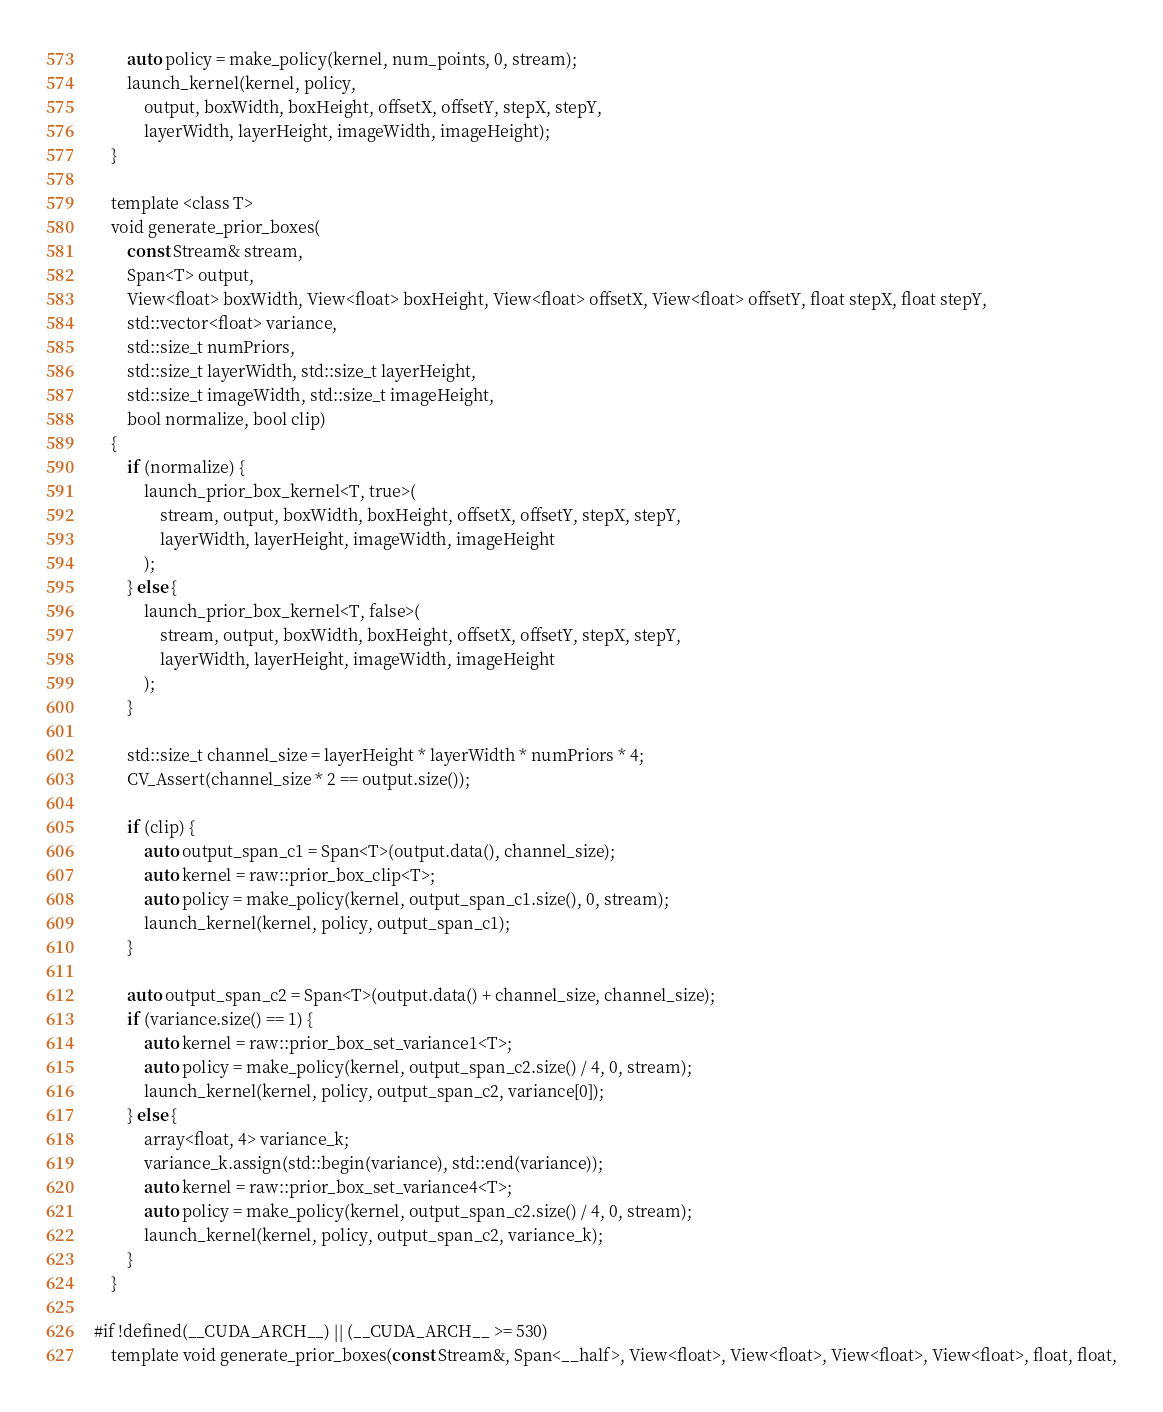Convert code to text. <code><loc_0><loc_0><loc_500><loc_500><_Cuda_>        auto policy = make_policy(kernel, num_points, 0, stream);
        launch_kernel(kernel, policy,
            output, boxWidth, boxHeight, offsetX, offsetY, stepX, stepY,
            layerWidth, layerHeight, imageWidth, imageHeight);
    }

    template <class T>
    void generate_prior_boxes(
        const Stream& stream,
        Span<T> output,
        View<float> boxWidth, View<float> boxHeight, View<float> offsetX, View<float> offsetY, float stepX, float stepY,
        std::vector<float> variance,
        std::size_t numPriors,
        std::size_t layerWidth, std::size_t layerHeight,
        std::size_t imageWidth, std::size_t imageHeight,
        bool normalize, bool clip)
    {
        if (normalize) {
            launch_prior_box_kernel<T, true>(
                stream, output, boxWidth, boxHeight, offsetX, offsetY, stepX, stepY,
                layerWidth, layerHeight, imageWidth, imageHeight
            );
        } else {
            launch_prior_box_kernel<T, false>(
                stream, output, boxWidth, boxHeight, offsetX, offsetY, stepX, stepY,
                layerWidth, layerHeight, imageWidth, imageHeight
            );
        }

        std::size_t channel_size = layerHeight * layerWidth * numPriors * 4;
        CV_Assert(channel_size * 2 == output.size());

        if (clip) {
            auto output_span_c1 = Span<T>(output.data(), channel_size);
            auto kernel = raw::prior_box_clip<T>;
            auto policy = make_policy(kernel, output_span_c1.size(), 0, stream);
            launch_kernel(kernel, policy, output_span_c1);
        }

        auto output_span_c2 = Span<T>(output.data() + channel_size, channel_size);
        if (variance.size() == 1) {
            auto kernel = raw::prior_box_set_variance1<T>;
            auto policy = make_policy(kernel, output_span_c2.size() / 4, 0, stream);
            launch_kernel(kernel, policy, output_span_c2, variance[0]);
        } else {
            array<float, 4> variance_k;
            variance_k.assign(std::begin(variance), std::end(variance));
            auto kernel = raw::prior_box_set_variance4<T>;
            auto policy = make_policy(kernel, output_span_c2.size() / 4, 0, stream);
            launch_kernel(kernel, policy, output_span_c2, variance_k);
        }
    }

#if !defined(__CUDA_ARCH__) || (__CUDA_ARCH__ >= 530)
    template void generate_prior_boxes(const Stream&, Span<__half>, View<float>, View<float>, View<float>, View<float>, float, float,</code> 